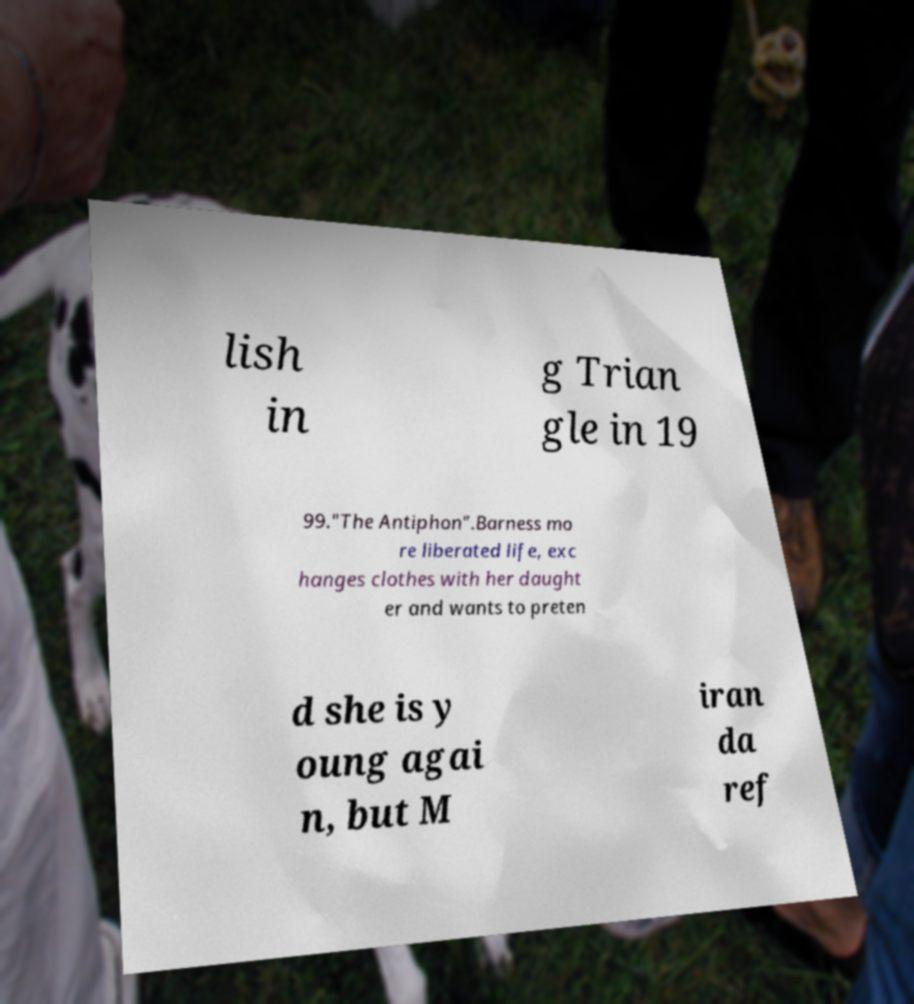Please read and relay the text visible in this image. What does it say? lish in g Trian gle in 19 99."The Antiphon".Barness mo re liberated life, exc hanges clothes with her daught er and wants to preten d she is y oung agai n, but M iran da ref 